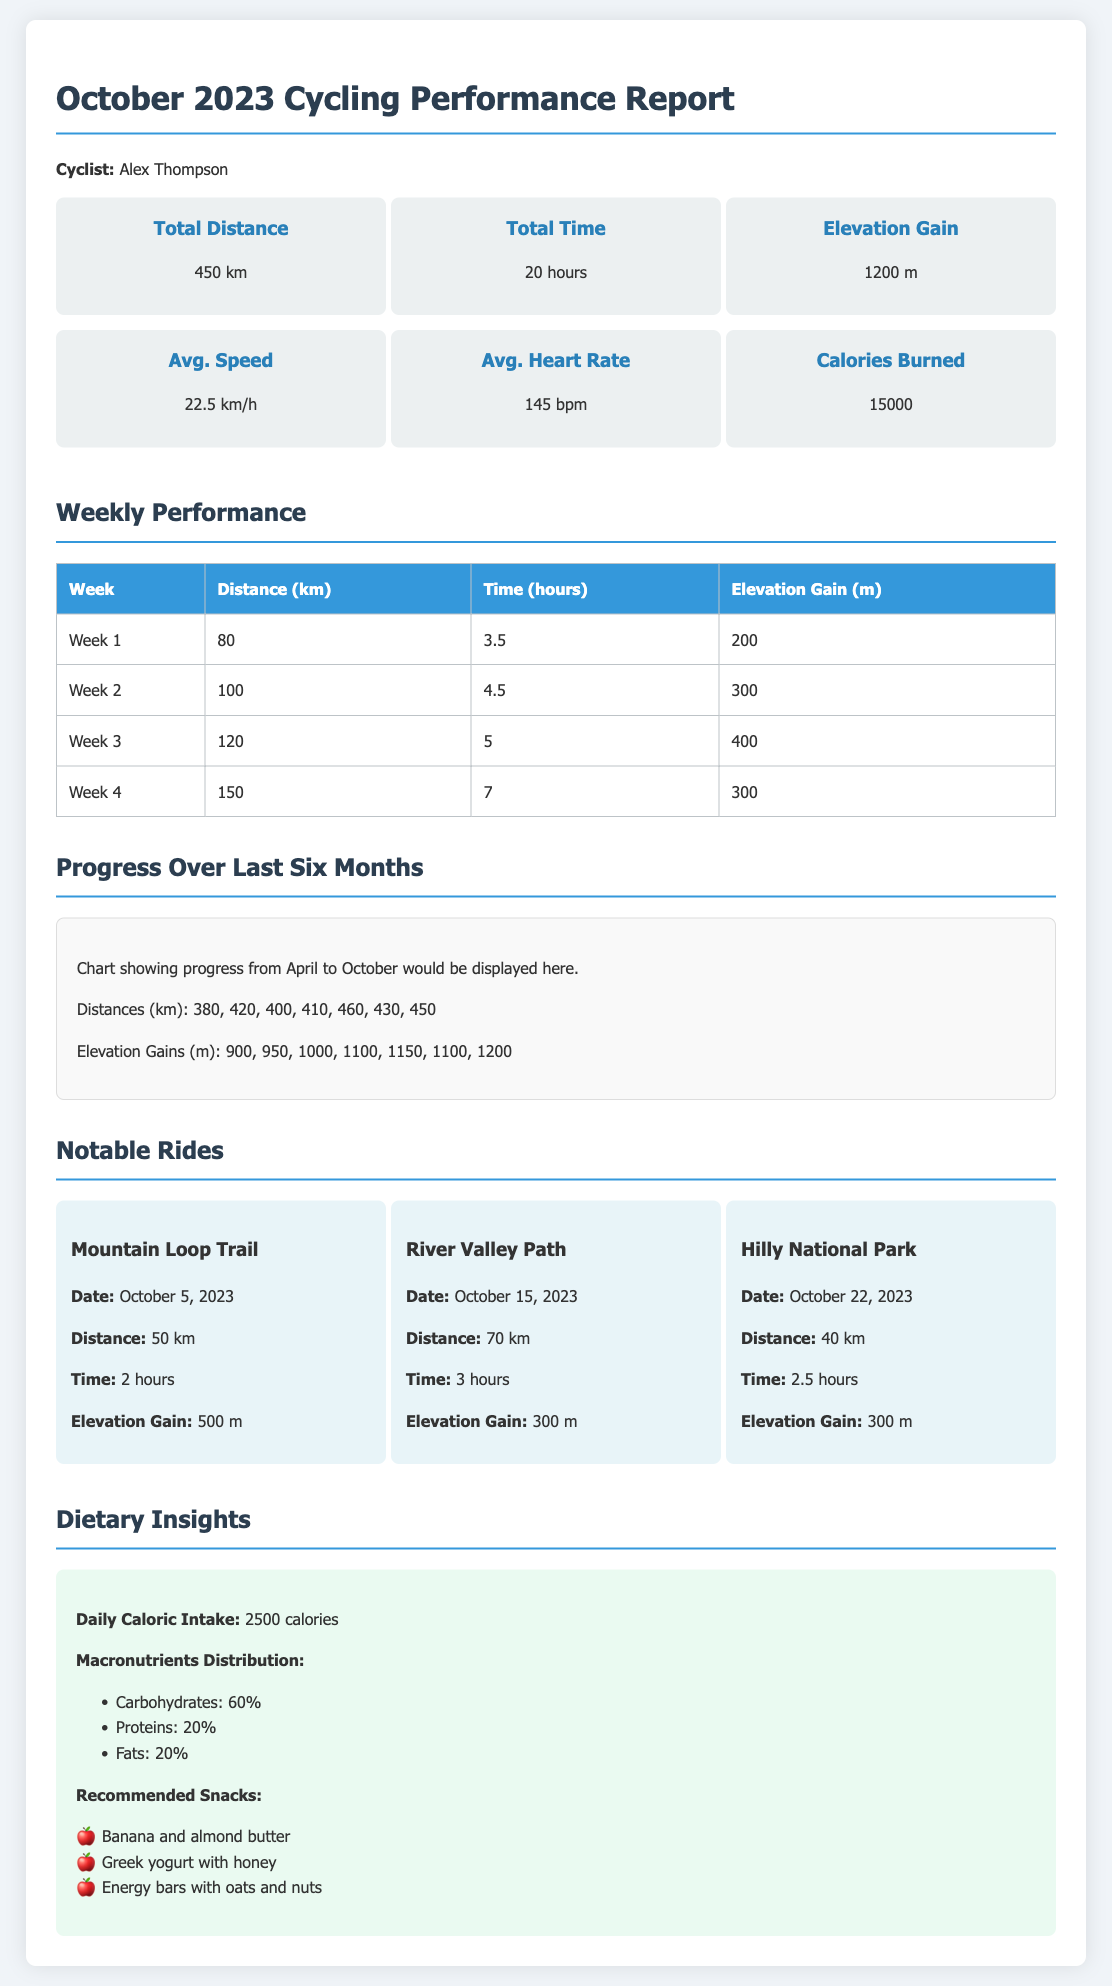What is the total distance cycled in October 2023? The document states that the total distance cycled in October 2023 is 450 km.
Answer: 450 km What is the average speed achieved? The average speed mentioned in the report is 22.5 km/h.
Answer: 22.5 km/h How many hours were spent cycling in total? The total time spent cycling is noted as 20 hours in the report.
Answer: 20 hours What was the elevation gain for Week 3? The elevation gain for Week 3 is listed as 400 m.
Answer: 400 m Which ride had the highest distance? The ride with the highest distance is the River Valley Path with 70 km.
Answer: River Valley Path How many calories were burned in total? The document indicates that 15,000 calories were burned overall.
Answer: 15000 What is the macronutrient distribution percentage for proteins? The report specifies that the protein distribution is 20%.
Answer: 20% Which notable ride had the longest time duration? The notable ride that had the longest time duration is the River Valley Path at 3 hours.
Answer: River Valley Path What was the distance for the first week? The distance for the first week is stated as 80 km.
Answer: 80 km 